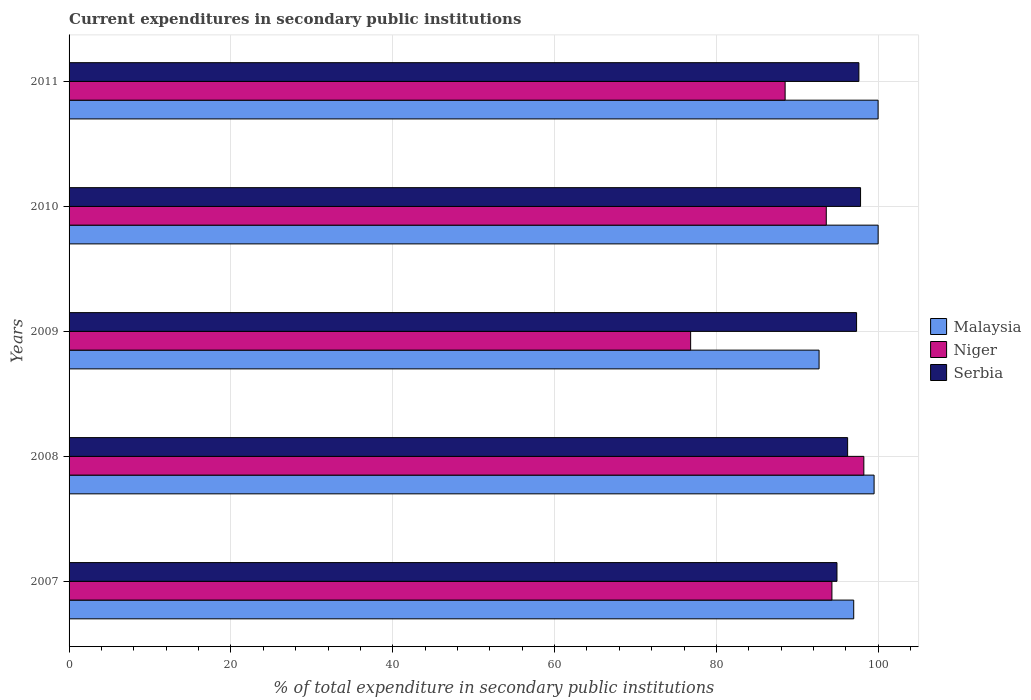How many groups of bars are there?
Keep it short and to the point. 5. Are the number of bars per tick equal to the number of legend labels?
Your response must be concise. Yes. In how many cases, is the number of bars for a given year not equal to the number of legend labels?
Make the answer very short. 0. What is the current expenditures in secondary public institutions in Malaysia in 2009?
Provide a short and direct response. 92.69. Across all years, what is the maximum current expenditures in secondary public institutions in Niger?
Make the answer very short. 98.22. Across all years, what is the minimum current expenditures in secondary public institutions in Niger?
Provide a short and direct response. 76.82. In which year was the current expenditures in secondary public institutions in Serbia maximum?
Keep it short and to the point. 2010. What is the total current expenditures in secondary public institutions in Malaysia in the graph?
Your answer should be compact. 489.11. What is the difference between the current expenditures in secondary public institutions in Niger in 2007 and that in 2009?
Your answer should be very brief. 17.46. What is the difference between the current expenditures in secondary public institutions in Niger in 2009 and the current expenditures in secondary public institutions in Malaysia in 2007?
Your response must be concise. -20.15. What is the average current expenditures in secondary public institutions in Niger per year?
Your answer should be compact. 90.28. In the year 2007, what is the difference between the current expenditures in secondary public institutions in Malaysia and current expenditures in secondary public institutions in Niger?
Provide a succinct answer. 2.69. What is the ratio of the current expenditures in secondary public institutions in Serbia in 2007 to that in 2008?
Ensure brevity in your answer.  0.99. Is the current expenditures in secondary public institutions in Serbia in 2008 less than that in 2010?
Provide a succinct answer. Yes. What is the difference between the highest and the second highest current expenditures in secondary public institutions in Niger?
Your answer should be very brief. 3.94. What is the difference between the highest and the lowest current expenditures in secondary public institutions in Malaysia?
Provide a short and direct response. 7.3. Is the sum of the current expenditures in secondary public institutions in Serbia in 2007 and 2008 greater than the maximum current expenditures in secondary public institutions in Malaysia across all years?
Your response must be concise. Yes. What does the 1st bar from the top in 2008 represents?
Your response must be concise. Serbia. What does the 1st bar from the bottom in 2008 represents?
Your answer should be very brief. Malaysia. Is it the case that in every year, the sum of the current expenditures in secondary public institutions in Serbia and current expenditures in secondary public institutions in Malaysia is greater than the current expenditures in secondary public institutions in Niger?
Provide a succinct answer. Yes. How many bars are there?
Your response must be concise. 15. How many years are there in the graph?
Ensure brevity in your answer.  5. How are the legend labels stacked?
Offer a very short reply. Vertical. What is the title of the graph?
Give a very brief answer. Current expenditures in secondary public institutions. What is the label or title of the X-axis?
Offer a very short reply. % of total expenditure in secondary public institutions. What is the % of total expenditure in secondary public institutions of Malaysia in 2007?
Make the answer very short. 96.97. What is the % of total expenditure in secondary public institutions in Niger in 2007?
Ensure brevity in your answer.  94.28. What is the % of total expenditure in secondary public institutions of Serbia in 2007?
Offer a terse response. 94.9. What is the % of total expenditure in secondary public institutions in Malaysia in 2008?
Offer a terse response. 99.49. What is the % of total expenditure in secondary public institutions in Niger in 2008?
Your response must be concise. 98.22. What is the % of total expenditure in secondary public institutions of Serbia in 2008?
Your response must be concise. 96.22. What is the % of total expenditure in secondary public institutions of Malaysia in 2009?
Offer a terse response. 92.69. What is the % of total expenditure in secondary public institutions of Niger in 2009?
Provide a succinct answer. 76.82. What is the % of total expenditure in secondary public institutions of Serbia in 2009?
Provide a short and direct response. 97.32. What is the % of total expenditure in secondary public institutions of Malaysia in 2010?
Make the answer very short. 99.99. What is the % of total expenditure in secondary public institutions of Niger in 2010?
Offer a terse response. 93.58. What is the % of total expenditure in secondary public institutions of Serbia in 2010?
Provide a short and direct response. 97.81. What is the % of total expenditure in secondary public institutions of Malaysia in 2011?
Offer a very short reply. 99.98. What is the % of total expenditure in secondary public institutions of Niger in 2011?
Your response must be concise. 88.49. What is the % of total expenditure in secondary public institutions of Serbia in 2011?
Make the answer very short. 97.61. Across all years, what is the maximum % of total expenditure in secondary public institutions of Malaysia?
Offer a terse response. 99.99. Across all years, what is the maximum % of total expenditure in secondary public institutions in Niger?
Make the answer very short. 98.22. Across all years, what is the maximum % of total expenditure in secondary public institutions in Serbia?
Provide a short and direct response. 97.81. Across all years, what is the minimum % of total expenditure in secondary public institutions in Malaysia?
Give a very brief answer. 92.69. Across all years, what is the minimum % of total expenditure in secondary public institutions of Niger?
Give a very brief answer. 76.82. Across all years, what is the minimum % of total expenditure in secondary public institutions in Serbia?
Provide a succinct answer. 94.9. What is the total % of total expenditure in secondary public institutions of Malaysia in the graph?
Make the answer very short. 489.11. What is the total % of total expenditure in secondary public institutions of Niger in the graph?
Offer a very short reply. 451.39. What is the total % of total expenditure in secondary public institutions in Serbia in the graph?
Offer a very short reply. 483.86. What is the difference between the % of total expenditure in secondary public institutions in Malaysia in 2007 and that in 2008?
Make the answer very short. -2.52. What is the difference between the % of total expenditure in secondary public institutions of Niger in 2007 and that in 2008?
Provide a short and direct response. -3.94. What is the difference between the % of total expenditure in secondary public institutions in Serbia in 2007 and that in 2008?
Keep it short and to the point. -1.32. What is the difference between the % of total expenditure in secondary public institutions in Malaysia in 2007 and that in 2009?
Provide a short and direct response. 4.28. What is the difference between the % of total expenditure in secondary public institutions of Niger in 2007 and that in 2009?
Your answer should be very brief. 17.46. What is the difference between the % of total expenditure in secondary public institutions in Serbia in 2007 and that in 2009?
Offer a very short reply. -2.42. What is the difference between the % of total expenditure in secondary public institutions in Malaysia in 2007 and that in 2010?
Ensure brevity in your answer.  -3.02. What is the difference between the % of total expenditure in secondary public institutions in Niger in 2007 and that in 2010?
Keep it short and to the point. 0.7. What is the difference between the % of total expenditure in secondary public institutions of Serbia in 2007 and that in 2010?
Ensure brevity in your answer.  -2.92. What is the difference between the % of total expenditure in secondary public institutions in Malaysia in 2007 and that in 2011?
Give a very brief answer. -3.01. What is the difference between the % of total expenditure in secondary public institutions in Niger in 2007 and that in 2011?
Provide a short and direct response. 5.78. What is the difference between the % of total expenditure in secondary public institutions in Serbia in 2007 and that in 2011?
Provide a succinct answer. -2.71. What is the difference between the % of total expenditure in secondary public institutions in Malaysia in 2008 and that in 2009?
Ensure brevity in your answer.  6.8. What is the difference between the % of total expenditure in secondary public institutions in Niger in 2008 and that in 2009?
Your answer should be compact. 21.4. What is the difference between the % of total expenditure in secondary public institutions in Serbia in 2008 and that in 2009?
Provide a short and direct response. -1.11. What is the difference between the % of total expenditure in secondary public institutions of Malaysia in 2008 and that in 2010?
Your answer should be very brief. -0.5. What is the difference between the % of total expenditure in secondary public institutions of Niger in 2008 and that in 2010?
Provide a succinct answer. 4.64. What is the difference between the % of total expenditure in secondary public institutions in Serbia in 2008 and that in 2010?
Your answer should be compact. -1.6. What is the difference between the % of total expenditure in secondary public institutions in Malaysia in 2008 and that in 2011?
Your response must be concise. -0.49. What is the difference between the % of total expenditure in secondary public institutions of Niger in 2008 and that in 2011?
Provide a succinct answer. 9.73. What is the difference between the % of total expenditure in secondary public institutions of Serbia in 2008 and that in 2011?
Your answer should be compact. -1.39. What is the difference between the % of total expenditure in secondary public institutions in Malaysia in 2009 and that in 2010?
Your answer should be very brief. -7.3. What is the difference between the % of total expenditure in secondary public institutions of Niger in 2009 and that in 2010?
Give a very brief answer. -16.76. What is the difference between the % of total expenditure in secondary public institutions of Serbia in 2009 and that in 2010?
Offer a terse response. -0.49. What is the difference between the % of total expenditure in secondary public institutions in Malaysia in 2009 and that in 2011?
Ensure brevity in your answer.  -7.29. What is the difference between the % of total expenditure in secondary public institutions of Niger in 2009 and that in 2011?
Give a very brief answer. -11.68. What is the difference between the % of total expenditure in secondary public institutions of Serbia in 2009 and that in 2011?
Your answer should be very brief. -0.29. What is the difference between the % of total expenditure in secondary public institutions in Malaysia in 2010 and that in 2011?
Provide a short and direct response. 0.01. What is the difference between the % of total expenditure in secondary public institutions in Niger in 2010 and that in 2011?
Give a very brief answer. 5.09. What is the difference between the % of total expenditure in secondary public institutions in Serbia in 2010 and that in 2011?
Provide a succinct answer. 0.21. What is the difference between the % of total expenditure in secondary public institutions of Malaysia in 2007 and the % of total expenditure in secondary public institutions of Niger in 2008?
Offer a very short reply. -1.25. What is the difference between the % of total expenditure in secondary public institutions in Malaysia in 2007 and the % of total expenditure in secondary public institutions in Serbia in 2008?
Provide a short and direct response. 0.75. What is the difference between the % of total expenditure in secondary public institutions of Niger in 2007 and the % of total expenditure in secondary public institutions of Serbia in 2008?
Make the answer very short. -1.94. What is the difference between the % of total expenditure in secondary public institutions of Malaysia in 2007 and the % of total expenditure in secondary public institutions of Niger in 2009?
Offer a terse response. 20.15. What is the difference between the % of total expenditure in secondary public institutions in Malaysia in 2007 and the % of total expenditure in secondary public institutions in Serbia in 2009?
Ensure brevity in your answer.  -0.35. What is the difference between the % of total expenditure in secondary public institutions of Niger in 2007 and the % of total expenditure in secondary public institutions of Serbia in 2009?
Give a very brief answer. -3.05. What is the difference between the % of total expenditure in secondary public institutions in Malaysia in 2007 and the % of total expenditure in secondary public institutions in Niger in 2010?
Your answer should be compact. 3.39. What is the difference between the % of total expenditure in secondary public institutions in Malaysia in 2007 and the % of total expenditure in secondary public institutions in Serbia in 2010?
Offer a very short reply. -0.85. What is the difference between the % of total expenditure in secondary public institutions of Niger in 2007 and the % of total expenditure in secondary public institutions of Serbia in 2010?
Your answer should be compact. -3.54. What is the difference between the % of total expenditure in secondary public institutions in Malaysia in 2007 and the % of total expenditure in secondary public institutions in Niger in 2011?
Offer a terse response. 8.48. What is the difference between the % of total expenditure in secondary public institutions of Malaysia in 2007 and the % of total expenditure in secondary public institutions of Serbia in 2011?
Keep it short and to the point. -0.64. What is the difference between the % of total expenditure in secondary public institutions of Niger in 2007 and the % of total expenditure in secondary public institutions of Serbia in 2011?
Provide a short and direct response. -3.33. What is the difference between the % of total expenditure in secondary public institutions in Malaysia in 2008 and the % of total expenditure in secondary public institutions in Niger in 2009?
Make the answer very short. 22.67. What is the difference between the % of total expenditure in secondary public institutions of Malaysia in 2008 and the % of total expenditure in secondary public institutions of Serbia in 2009?
Offer a very short reply. 2.16. What is the difference between the % of total expenditure in secondary public institutions in Niger in 2008 and the % of total expenditure in secondary public institutions in Serbia in 2009?
Give a very brief answer. 0.9. What is the difference between the % of total expenditure in secondary public institutions of Malaysia in 2008 and the % of total expenditure in secondary public institutions of Niger in 2010?
Your answer should be compact. 5.91. What is the difference between the % of total expenditure in secondary public institutions in Malaysia in 2008 and the % of total expenditure in secondary public institutions in Serbia in 2010?
Ensure brevity in your answer.  1.67. What is the difference between the % of total expenditure in secondary public institutions in Niger in 2008 and the % of total expenditure in secondary public institutions in Serbia in 2010?
Keep it short and to the point. 0.41. What is the difference between the % of total expenditure in secondary public institutions of Malaysia in 2008 and the % of total expenditure in secondary public institutions of Niger in 2011?
Your response must be concise. 10.99. What is the difference between the % of total expenditure in secondary public institutions of Malaysia in 2008 and the % of total expenditure in secondary public institutions of Serbia in 2011?
Provide a short and direct response. 1.88. What is the difference between the % of total expenditure in secondary public institutions of Niger in 2008 and the % of total expenditure in secondary public institutions of Serbia in 2011?
Your answer should be compact. 0.61. What is the difference between the % of total expenditure in secondary public institutions of Malaysia in 2009 and the % of total expenditure in secondary public institutions of Niger in 2010?
Make the answer very short. -0.89. What is the difference between the % of total expenditure in secondary public institutions in Malaysia in 2009 and the % of total expenditure in secondary public institutions in Serbia in 2010?
Give a very brief answer. -5.13. What is the difference between the % of total expenditure in secondary public institutions of Niger in 2009 and the % of total expenditure in secondary public institutions of Serbia in 2010?
Offer a very short reply. -21. What is the difference between the % of total expenditure in secondary public institutions in Malaysia in 2009 and the % of total expenditure in secondary public institutions in Niger in 2011?
Your answer should be compact. 4.19. What is the difference between the % of total expenditure in secondary public institutions in Malaysia in 2009 and the % of total expenditure in secondary public institutions in Serbia in 2011?
Ensure brevity in your answer.  -4.92. What is the difference between the % of total expenditure in secondary public institutions of Niger in 2009 and the % of total expenditure in secondary public institutions of Serbia in 2011?
Offer a terse response. -20.79. What is the difference between the % of total expenditure in secondary public institutions in Malaysia in 2010 and the % of total expenditure in secondary public institutions in Niger in 2011?
Offer a terse response. 11.49. What is the difference between the % of total expenditure in secondary public institutions of Malaysia in 2010 and the % of total expenditure in secondary public institutions of Serbia in 2011?
Your response must be concise. 2.38. What is the difference between the % of total expenditure in secondary public institutions in Niger in 2010 and the % of total expenditure in secondary public institutions in Serbia in 2011?
Ensure brevity in your answer.  -4.03. What is the average % of total expenditure in secondary public institutions of Malaysia per year?
Ensure brevity in your answer.  97.82. What is the average % of total expenditure in secondary public institutions of Niger per year?
Ensure brevity in your answer.  90.28. What is the average % of total expenditure in secondary public institutions in Serbia per year?
Your answer should be very brief. 96.77. In the year 2007, what is the difference between the % of total expenditure in secondary public institutions in Malaysia and % of total expenditure in secondary public institutions in Niger?
Make the answer very short. 2.69. In the year 2007, what is the difference between the % of total expenditure in secondary public institutions in Malaysia and % of total expenditure in secondary public institutions in Serbia?
Keep it short and to the point. 2.07. In the year 2007, what is the difference between the % of total expenditure in secondary public institutions of Niger and % of total expenditure in secondary public institutions of Serbia?
Your response must be concise. -0.62. In the year 2008, what is the difference between the % of total expenditure in secondary public institutions of Malaysia and % of total expenditure in secondary public institutions of Niger?
Your answer should be compact. 1.27. In the year 2008, what is the difference between the % of total expenditure in secondary public institutions in Malaysia and % of total expenditure in secondary public institutions in Serbia?
Keep it short and to the point. 3.27. In the year 2008, what is the difference between the % of total expenditure in secondary public institutions of Niger and % of total expenditure in secondary public institutions of Serbia?
Your response must be concise. 2. In the year 2009, what is the difference between the % of total expenditure in secondary public institutions in Malaysia and % of total expenditure in secondary public institutions in Niger?
Offer a terse response. 15.87. In the year 2009, what is the difference between the % of total expenditure in secondary public institutions in Malaysia and % of total expenditure in secondary public institutions in Serbia?
Offer a very short reply. -4.64. In the year 2009, what is the difference between the % of total expenditure in secondary public institutions of Niger and % of total expenditure in secondary public institutions of Serbia?
Provide a succinct answer. -20.51. In the year 2010, what is the difference between the % of total expenditure in secondary public institutions of Malaysia and % of total expenditure in secondary public institutions of Niger?
Your response must be concise. 6.41. In the year 2010, what is the difference between the % of total expenditure in secondary public institutions of Malaysia and % of total expenditure in secondary public institutions of Serbia?
Offer a terse response. 2.17. In the year 2010, what is the difference between the % of total expenditure in secondary public institutions of Niger and % of total expenditure in secondary public institutions of Serbia?
Your response must be concise. -4.24. In the year 2011, what is the difference between the % of total expenditure in secondary public institutions in Malaysia and % of total expenditure in secondary public institutions in Niger?
Keep it short and to the point. 11.49. In the year 2011, what is the difference between the % of total expenditure in secondary public institutions of Malaysia and % of total expenditure in secondary public institutions of Serbia?
Make the answer very short. 2.37. In the year 2011, what is the difference between the % of total expenditure in secondary public institutions of Niger and % of total expenditure in secondary public institutions of Serbia?
Give a very brief answer. -9.12. What is the ratio of the % of total expenditure in secondary public institutions of Malaysia in 2007 to that in 2008?
Your answer should be compact. 0.97. What is the ratio of the % of total expenditure in secondary public institutions in Niger in 2007 to that in 2008?
Offer a very short reply. 0.96. What is the ratio of the % of total expenditure in secondary public institutions in Serbia in 2007 to that in 2008?
Give a very brief answer. 0.99. What is the ratio of the % of total expenditure in secondary public institutions in Malaysia in 2007 to that in 2009?
Your answer should be very brief. 1.05. What is the ratio of the % of total expenditure in secondary public institutions in Niger in 2007 to that in 2009?
Give a very brief answer. 1.23. What is the ratio of the % of total expenditure in secondary public institutions in Serbia in 2007 to that in 2009?
Provide a succinct answer. 0.98. What is the ratio of the % of total expenditure in secondary public institutions in Malaysia in 2007 to that in 2010?
Ensure brevity in your answer.  0.97. What is the ratio of the % of total expenditure in secondary public institutions of Niger in 2007 to that in 2010?
Provide a short and direct response. 1.01. What is the ratio of the % of total expenditure in secondary public institutions in Serbia in 2007 to that in 2010?
Ensure brevity in your answer.  0.97. What is the ratio of the % of total expenditure in secondary public institutions in Malaysia in 2007 to that in 2011?
Provide a short and direct response. 0.97. What is the ratio of the % of total expenditure in secondary public institutions of Niger in 2007 to that in 2011?
Your response must be concise. 1.07. What is the ratio of the % of total expenditure in secondary public institutions of Serbia in 2007 to that in 2011?
Keep it short and to the point. 0.97. What is the ratio of the % of total expenditure in secondary public institutions in Malaysia in 2008 to that in 2009?
Make the answer very short. 1.07. What is the ratio of the % of total expenditure in secondary public institutions of Niger in 2008 to that in 2009?
Provide a succinct answer. 1.28. What is the ratio of the % of total expenditure in secondary public institutions in Serbia in 2008 to that in 2009?
Make the answer very short. 0.99. What is the ratio of the % of total expenditure in secondary public institutions of Niger in 2008 to that in 2010?
Keep it short and to the point. 1.05. What is the ratio of the % of total expenditure in secondary public institutions of Serbia in 2008 to that in 2010?
Your answer should be very brief. 0.98. What is the ratio of the % of total expenditure in secondary public institutions in Niger in 2008 to that in 2011?
Provide a short and direct response. 1.11. What is the ratio of the % of total expenditure in secondary public institutions in Serbia in 2008 to that in 2011?
Offer a very short reply. 0.99. What is the ratio of the % of total expenditure in secondary public institutions in Malaysia in 2009 to that in 2010?
Keep it short and to the point. 0.93. What is the ratio of the % of total expenditure in secondary public institutions in Niger in 2009 to that in 2010?
Your response must be concise. 0.82. What is the ratio of the % of total expenditure in secondary public institutions in Malaysia in 2009 to that in 2011?
Your answer should be very brief. 0.93. What is the ratio of the % of total expenditure in secondary public institutions of Niger in 2009 to that in 2011?
Ensure brevity in your answer.  0.87. What is the ratio of the % of total expenditure in secondary public institutions of Serbia in 2009 to that in 2011?
Ensure brevity in your answer.  1. What is the ratio of the % of total expenditure in secondary public institutions in Niger in 2010 to that in 2011?
Make the answer very short. 1.06. What is the ratio of the % of total expenditure in secondary public institutions in Serbia in 2010 to that in 2011?
Make the answer very short. 1. What is the difference between the highest and the second highest % of total expenditure in secondary public institutions of Malaysia?
Provide a short and direct response. 0.01. What is the difference between the highest and the second highest % of total expenditure in secondary public institutions of Niger?
Your answer should be compact. 3.94. What is the difference between the highest and the second highest % of total expenditure in secondary public institutions in Serbia?
Provide a short and direct response. 0.21. What is the difference between the highest and the lowest % of total expenditure in secondary public institutions in Malaysia?
Ensure brevity in your answer.  7.3. What is the difference between the highest and the lowest % of total expenditure in secondary public institutions of Niger?
Ensure brevity in your answer.  21.4. What is the difference between the highest and the lowest % of total expenditure in secondary public institutions of Serbia?
Keep it short and to the point. 2.92. 